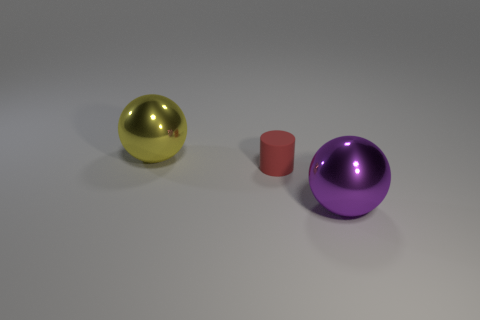There is a thing that is both left of the purple sphere and in front of the yellow metal sphere; what size is it?
Provide a short and direct response. Small. Is the color of the large metal object that is on the left side of the big purple ball the same as the large thing that is to the right of the big yellow sphere?
Provide a short and direct response. No. What number of other things are there of the same material as the big purple object
Provide a short and direct response. 1. What shape is the object that is on the right side of the large yellow ball and to the left of the purple sphere?
Your answer should be very brief. Cylinder. There is a small rubber thing; is its color the same as the large metallic object that is behind the tiny cylinder?
Keep it short and to the point. No. There is a shiny sphere in front of the cylinder; does it have the same size as the small red object?
Offer a very short reply. No. There is a yellow object that is the same shape as the purple metallic thing; what material is it?
Your response must be concise. Metal. Is the shape of the red rubber object the same as the purple thing?
Offer a terse response. No. There is a shiny sphere that is left of the red cylinder; how many purple metallic spheres are to the right of it?
Offer a terse response. 1. There is a purple object that is made of the same material as the big yellow object; what shape is it?
Give a very brief answer. Sphere. 